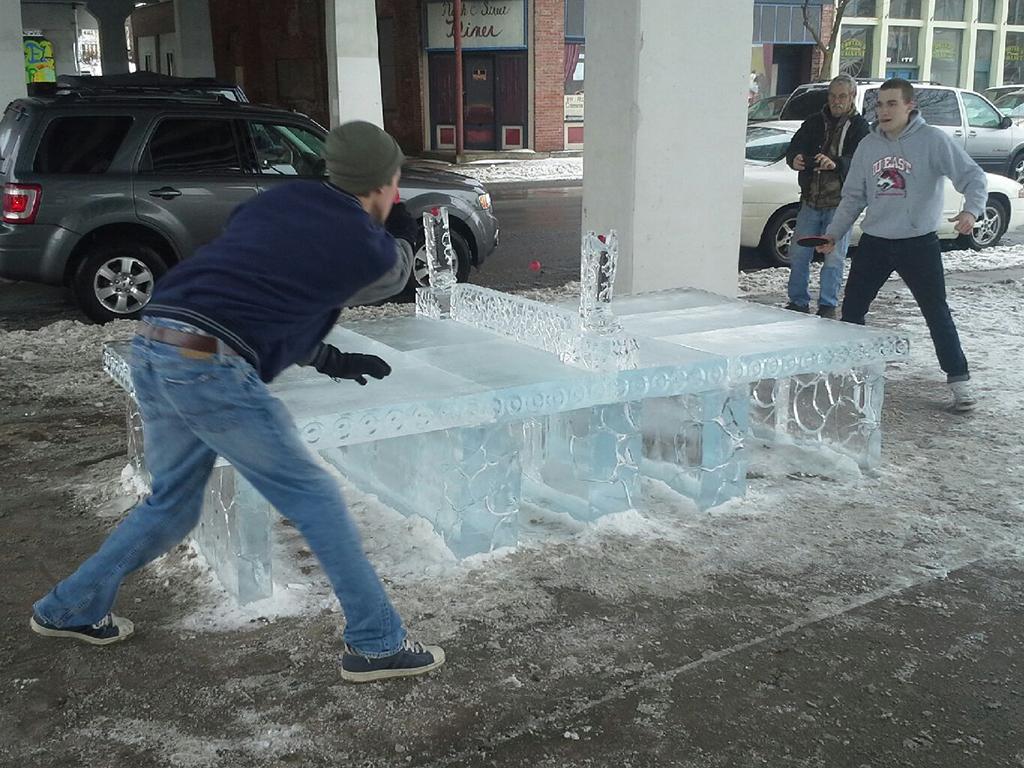In one or two sentences, can you explain what this image depicts? In this image there are three persons two of them are playing table tennis, and in the center there is an ice table. At the bottom there is walkway, and in the background there are buildings, vehicles, tree, poles and some boards and glass doors. 